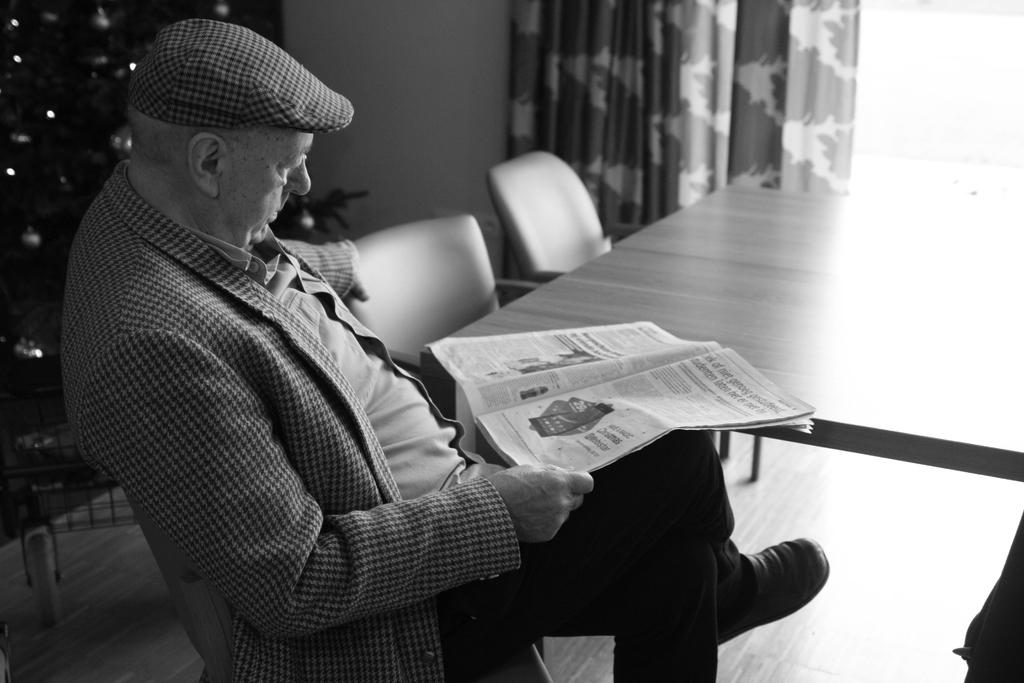What is the person in the image doing? The person is sitting in the image. What is the person holding? The person is holding papers. What type of furniture can be seen in the image? There are chairs and tables in the image. What type of window treatment is present in the image? There are curtains in the image. What is the color scheme of the image? The image is in black and white. What type of wool is being spun by the person in the image? There is no wool or spinning activity present in the image; the person is holding papers. 